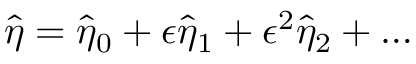Convert formula to latex. <formula><loc_0><loc_0><loc_500><loc_500>\hat { \eta } = \hat { \eta } _ { 0 } + \epsilon \hat { \eta } _ { 1 } + \epsilon ^ { 2 } \hat { \eta } _ { 2 } + \hdots</formula> 